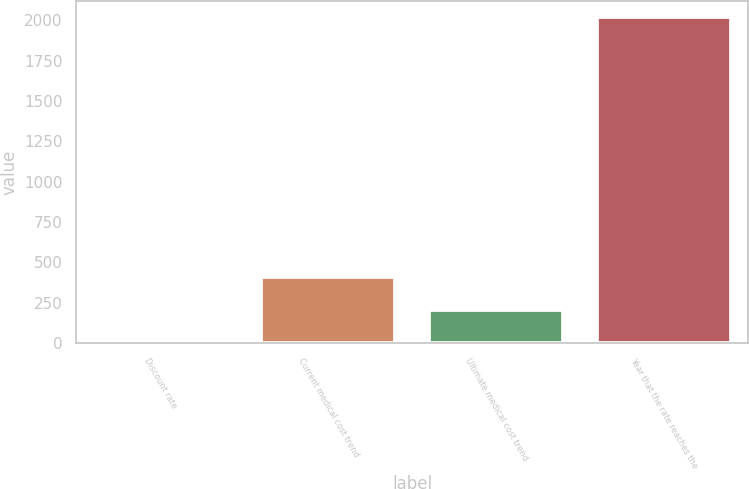Convert chart. <chart><loc_0><loc_0><loc_500><loc_500><bar_chart><fcel>Discount rate<fcel>Current medical cost trend<fcel>Ultimate medical cost trend<fcel>Year that the rate reaches the<nl><fcel>5<fcel>407.6<fcel>206.3<fcel>2018<nl></chart> 